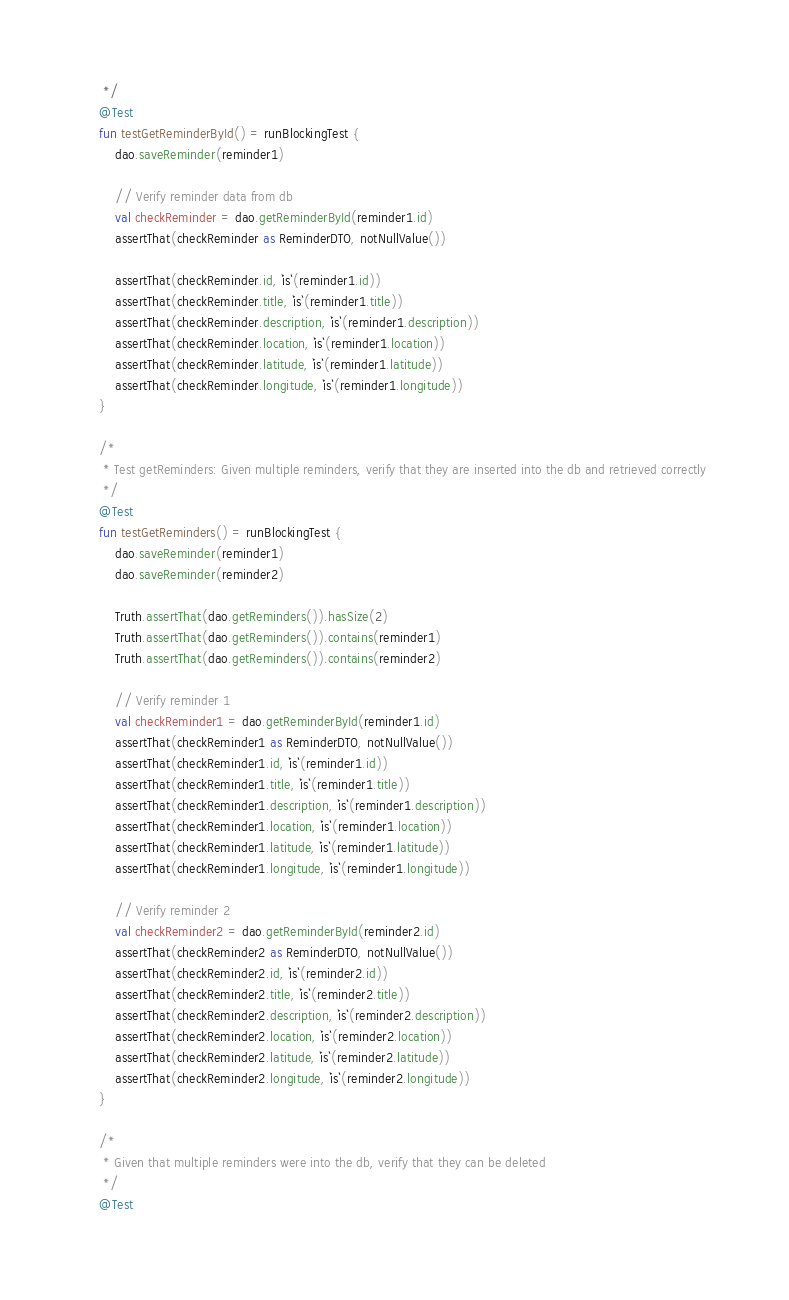Convert code to text. <code><loc_0><loc_0><loc_500><loc_500><_Kotlin_>     */
    @Test
    fun testGetReminderById() = runBlockingTest {
        dao.saveReminder(reminder1)

        // Verify reminder data from db
        val checkReminder = dao.getReminderById(reminder1.id)
        assertThat(checkReminder as ReminderDTO, notNullValue())

        assertThat(checkReminder.id, `is`(reminder1.id))
        assertThat(checkReminder.title, `is`(reminder1.title))
        assertThat(checkReminder.description, `is`(reminder1.description))
        assertThat(checkReminder.location, `is`(reminder1.location))
        assertThat(checkReminder.latitude, `is`(reminder1.latitude))
        assertThat(checkReminder.longitude, `is`(reminder1.longitude))
    }

    /*
     * Test getReminders: Given multiple reminders, verify that they are inserted into the db and retrieved correctly
     */
    @Test
    fun testGetReminders() = runBlockingTest {
        dao.saveReminder(reminder1)
        dao.saveReminder(reminder2)

        Truth.assertThat(dao.getReminders()).hasSize(2)
        Truth.assertThat(dao.getReminders()).contains(reminder1)
        Truth.assertThat(dao.getReminders()).contains(reminder2)

        // Verify reminder 1
        val checkReminder1 = dao.getReminderById(reminder1.id)
        assertThat(checkReminder1 as ReminderDTO, notNullValue())
        assertThat(checkReminder1.id, `is`(reminder1.id))
        assertThat(checkReminder1.title, `is`(reminder1.title))
        assertThat(checkReminder1.description, `is`(reminder1.description))
        assertThat(checkReminder1.location, `is`(reminder1.location))
        assertThat(checkReminder1.latitude, `is`(reminder1.latitude))
        assertThat(checkReminder1.longitude, `is`(reminder1.longitude))

        // Verify reminder 2
        val checkReminder2 = dao.getReminderById(reminder2.id)
        assertThat(checkReminder2 as ReminderDTO, notNullValue())
        assertThat(checkReminder2.id, `is`(reminder2.id))
        assertThat(checkReminder2.title, `is`(reminder2.title))
        assertThat(checkReminder2.description, `is`(reminder2.description))
        assertThat(checkReminder2.location, `is`(reminder2.location))
        assertThat(checkReminder2.latitude, `is`(reminder2.latitude))
        assertThat(checkReminder2.longitude, `is`(reminder2.longitude))
    }

    /*
     * Given that multiple reminders were into the db, verify that they can be deleted
     */
    @Test</code> 